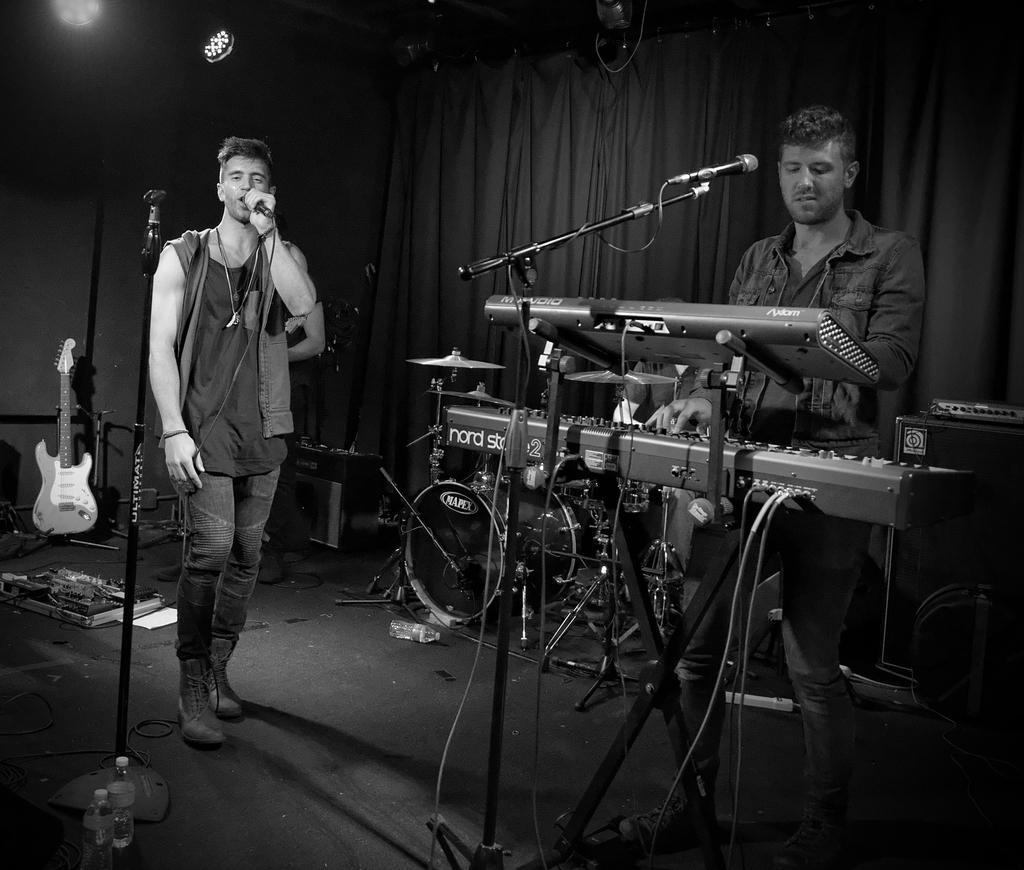Could you give a brief overview of what you see in this image? In the left a man is singing a song in the microphone and in the right a man is playing a musical instrument. Behind him there is a curtain. 